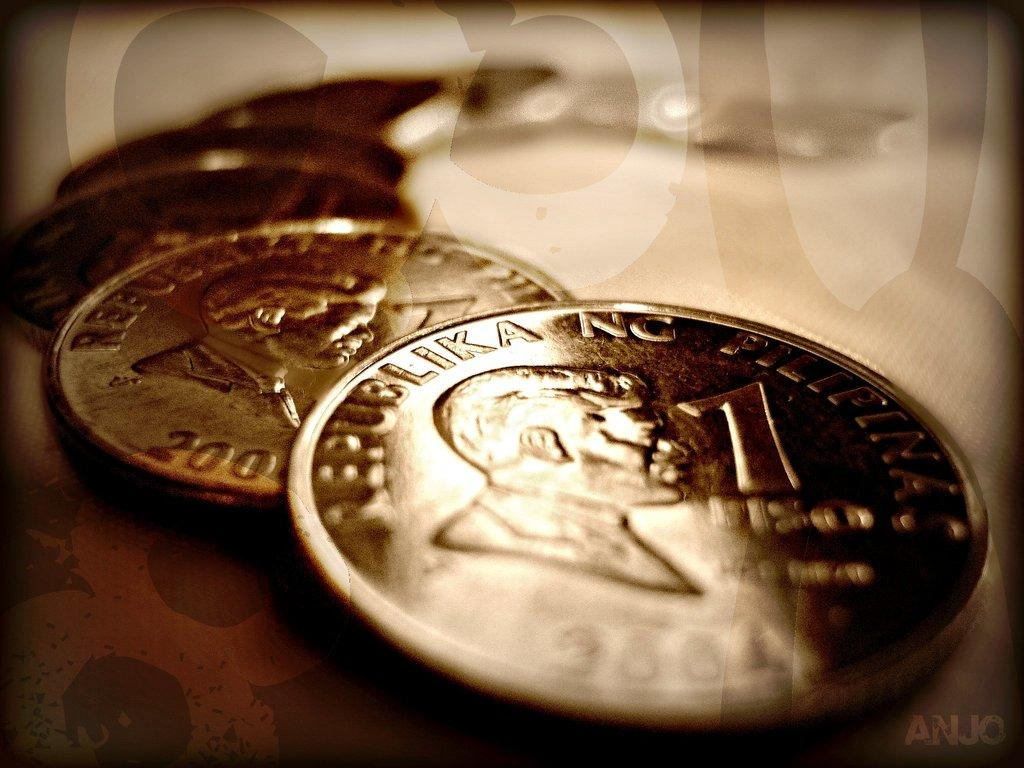<image>
Give a short and clear explanation of the subsequent image. Some coins from the Republic of Philippines with the head of a male figure on it. 